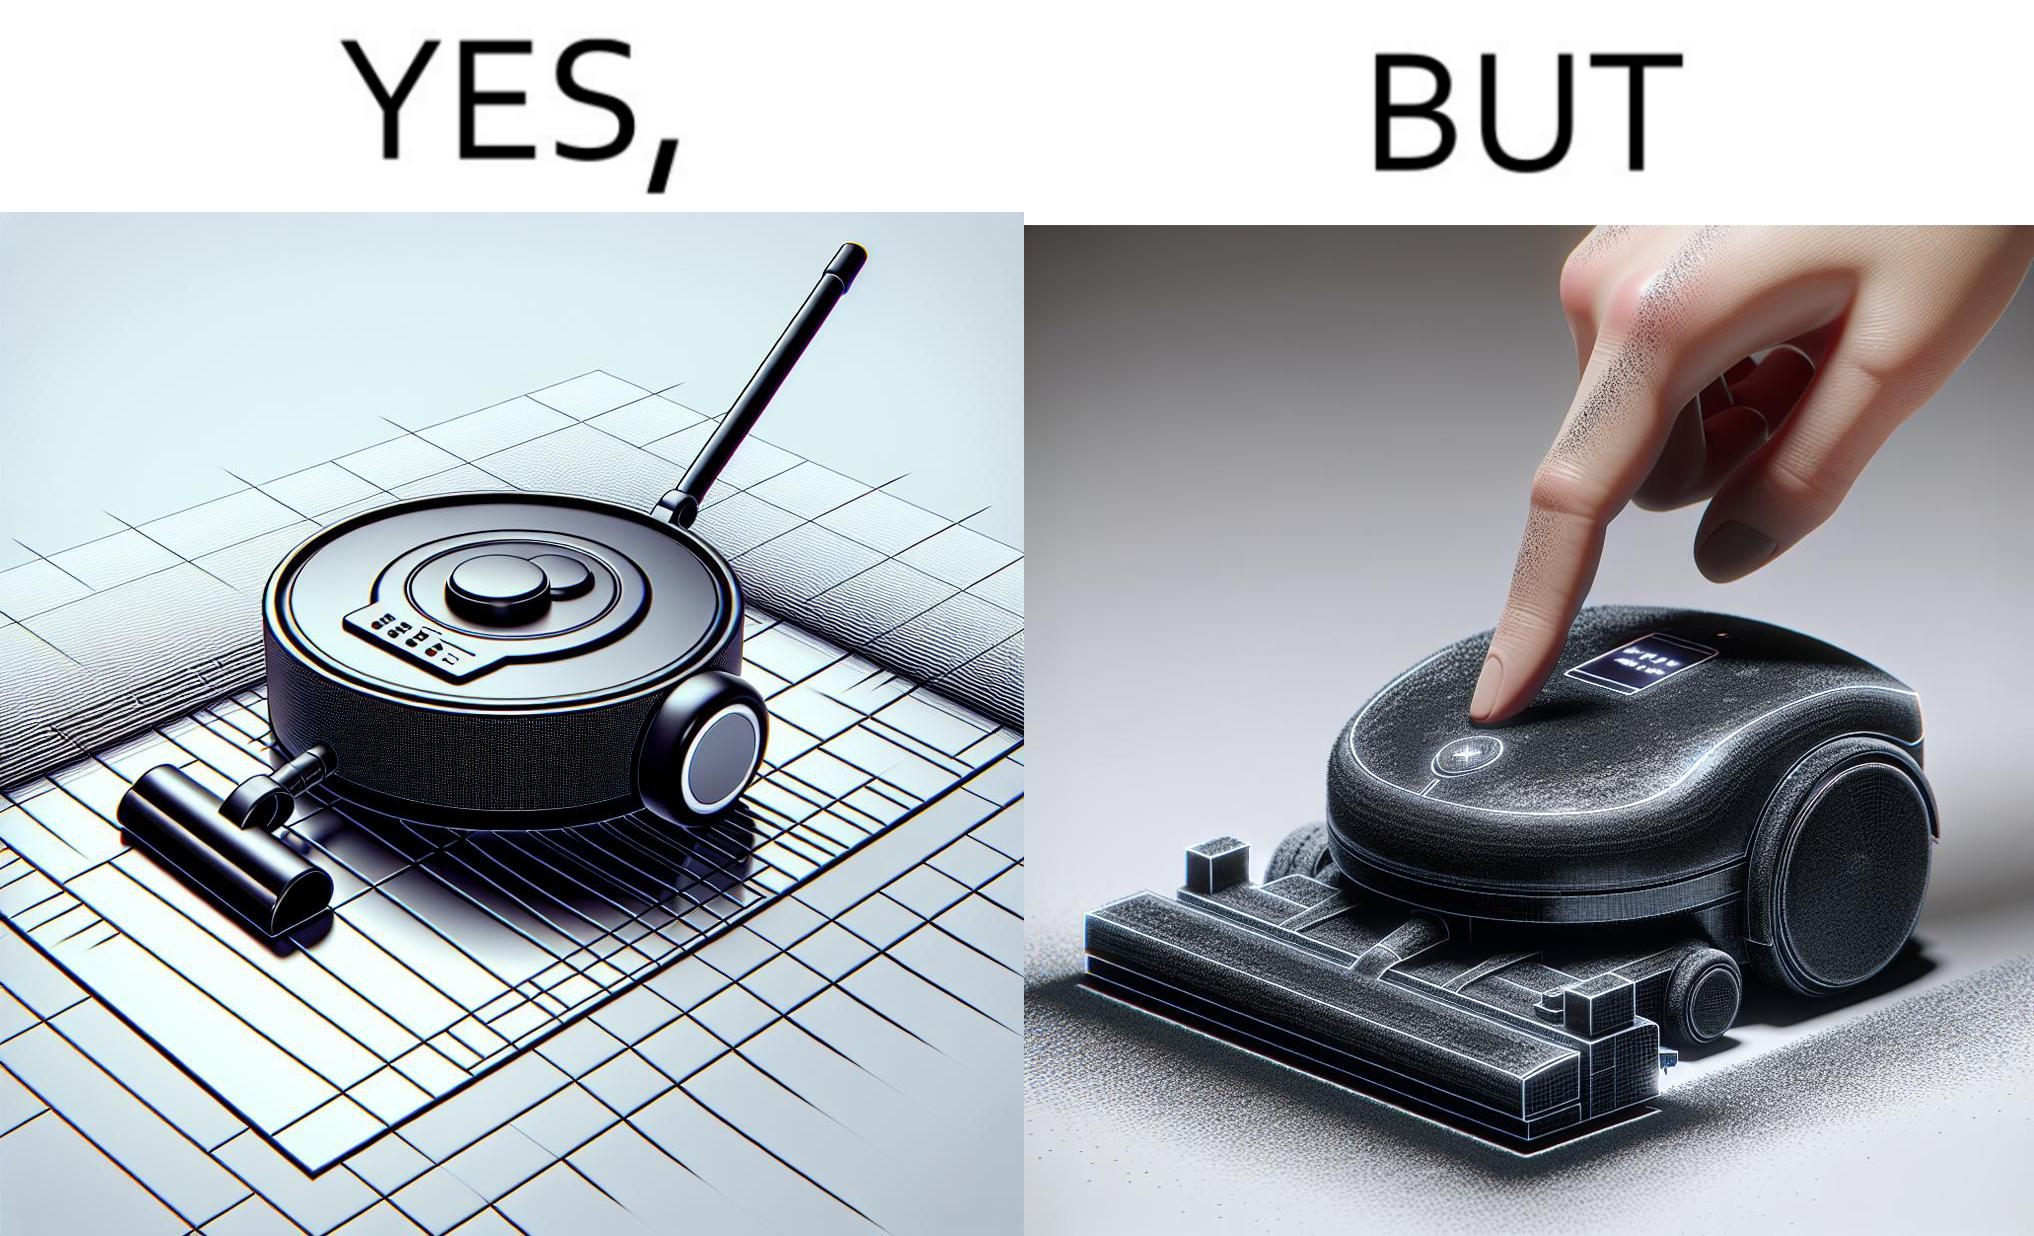Describe the content of this image. This is funny, because the machine while doing its job cleans everything but ends up being dirty itself. 